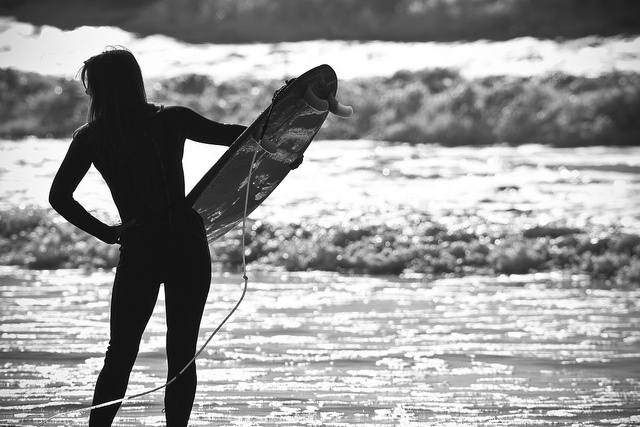Describe the objects in this image and their specific colors. I can see people in black, white, gray, and darkgray tones and surfboard in black, gray, darkgray, and lightgray tones in this image. 